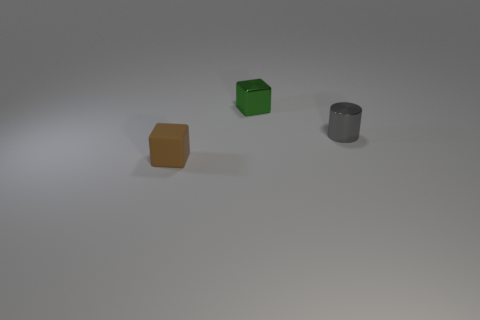The tiny shiny thing to the right of the tiny green thing has what shape?
Your answer should be very brief. Cylinder. Is there a small gray cylinder that is in front of the small cube that is in front of the small cylinder?
Your response must be concise. No. What number of green cubes have the same material as the small gray cylinder?
Offer a very short reply. 1. There is a cube on the right side of the block on the left side of the small object behind the tiny metal cylinder; what size is it?
Keep it short and to the point. Small. There is a small brown rubber block; how many brown rubber blocks are left of it?
Provide a succinct answer. 0. Is the number of brown shiny objects greater than the number of tiny gray things?
Provide a succinct answer. No. There is a object that is both in front of the green thing and behind the brown cube; how big is it?
Provide a short and direct response. Small. What material is the tiny cube right of the tiny block that is in front of the metal thing in front of the tiny shiny block?
Offer a very short reply. Metal. Does the tiny cube that is to the right of the brown cube have the same color as the tiny block in front of the gray cylinder?
Offer a very short reply. No. What is the shape of the thing that is in front of the metal thing to the right of the block on the right side of the small rubber block?
Offer a terse response. Cube. 